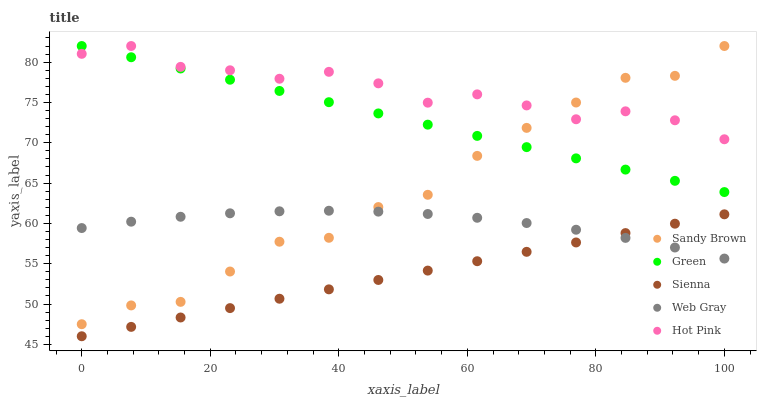Does Sienna have the minimum area under the curve?
Answer yes or no. Yes. Does Hot Pink have the maximum area under the curve?
Answer yes or no. Yes. Does Green have the minimum area under the curve?
Answer yes or no. No. Does Green have the maximum area under the curve?
Answer yes or no. No. Is Sienna the smoothest?
Answer yes or no. Yes. Is Sandy Brown the roughest?
Answer yes or no. Yes. Is Green the smoothest?
Answer yes or no. No. Is Green the roughest?
Answer yes or no. No. Does Sienna have the lowest value?
Answer yes or no. Yes. Does Green have the lowest value?
Answer yes or no. No. Does Hot Pink have the highest value?
Answer yes or no. Yes. Does Web Gray have the highest value?
Answer yes or no. No. Is Sienna less than Hot Pink?
Answer yes or no. Yes. Is Hot Pink greater than Web Gray?
Answer yes or no. Yes. Does Sandy Brown intersect Hot Pink?
Answer yes or no. Yes. Is Sandy Brown less than Hot Pink?
Answer yes or no. No. Is Sandy Brown greater than Hot Pink?
Answer yes or no. No. Does Sienna intersect Hot Pink?
Answer yes or no. No. 